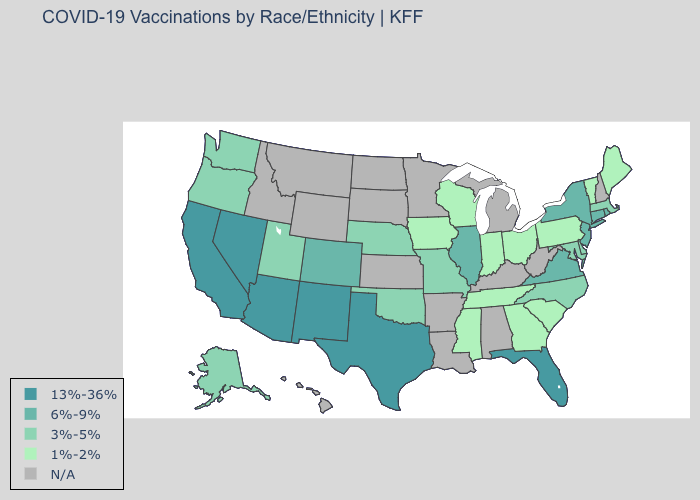How many symbols are there in the legend?
Quick response, please. 5. What is the lowest value in the West?
Answer briefly. 3%-5%. Does the first symbol in the legend represent the smallest category?
Keep it brief. No. Name the states that have a value in the range 1%-2%?
Concise answer only. Georgia, Indiana, Iowa, Maine, Mississippi, Ohio, Pennsylvania, South Carolina, Tennessee, Vermont, Wisconsin. Does Texas have the lowest value in the South?
Quick response, please. No. Name the states that have a value in the range 1%-2%?
Answer briefly. Georgia, Indiana, Iowa, Maine, Mississippi, Ohio, Pennsylvania, South Carolina, Tennessee, Vermont, Wisconsin. What is the value of Rhode Island?
Be succinct. 6%-9%. Name the states that have a value in the range 1%-2%?
Quick response, please. Georgia, Indiana, Iowa, Maine, Mississippi, Ohio, Pennsylvania, South Carolina, Tennessee, Vermont, Wisconsin. Does Maine have the highest value in the Northeast?
Write a very short answer. No. Name the states that have a value in the range 1%-2%?
Write a very short answer. Georgia, Indiana, Iowa, Maine, Mississippi, Ohio, Pennsylvania, South Carolina, Tennessee, Vermont, Wisconsin. Does Rhode Island have the highest value in the Northeast?
Concise answer only. Yes. Name the states that have a value in the range 1%-2%?
Give a very brief answer. Georgia, Indiana, Iowa, Maine, Mississippi, Ohio, Pennsylvania, South Carolina, Tennessee, Vermont, Wisconsin. Name the states that have a value in the range 13%-36%?
Quick response, please. Arizona, California, Florida, Nevada, New Mexico, Texas. What is the value of Utah?
Quick response, please. 3%-5%. 